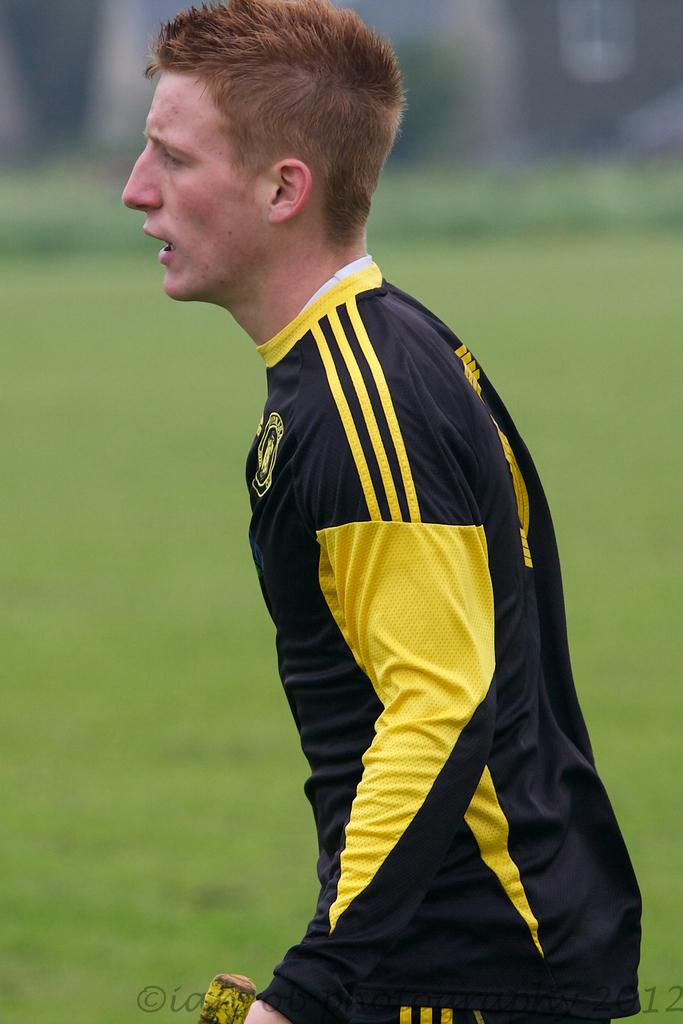What is the main subject of the image? There is a person standing in the image. What type of terrain is the person standing on? The person is standing on grassland. Can you describe the background of the image? The background of the image is blurry. What type of snail can be seen crawling on the person's arm in the image? There is no snail present on the person's arm in the image. What type of plant is growing on the person's head in the image? There is no plant growing on the person's head in the image. 